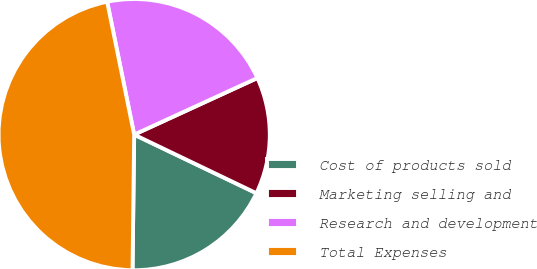Convert chart to OTSL. <chart><loc_0><loc_0><loc_500><loc_500><pie_chart><fcel>Cost of products sold<fcel>Marketing selling and<fcel>Research and development<fcel>Total Expenses<nl><fcel>18.08%<fcel>13.97%<fcel>21.34%<fcel>46.62%<nl></chart> 